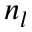Convert formula to latex. <formula><loc_0><loc_0><loc_500><loc_500>n _ { l }</formula> 